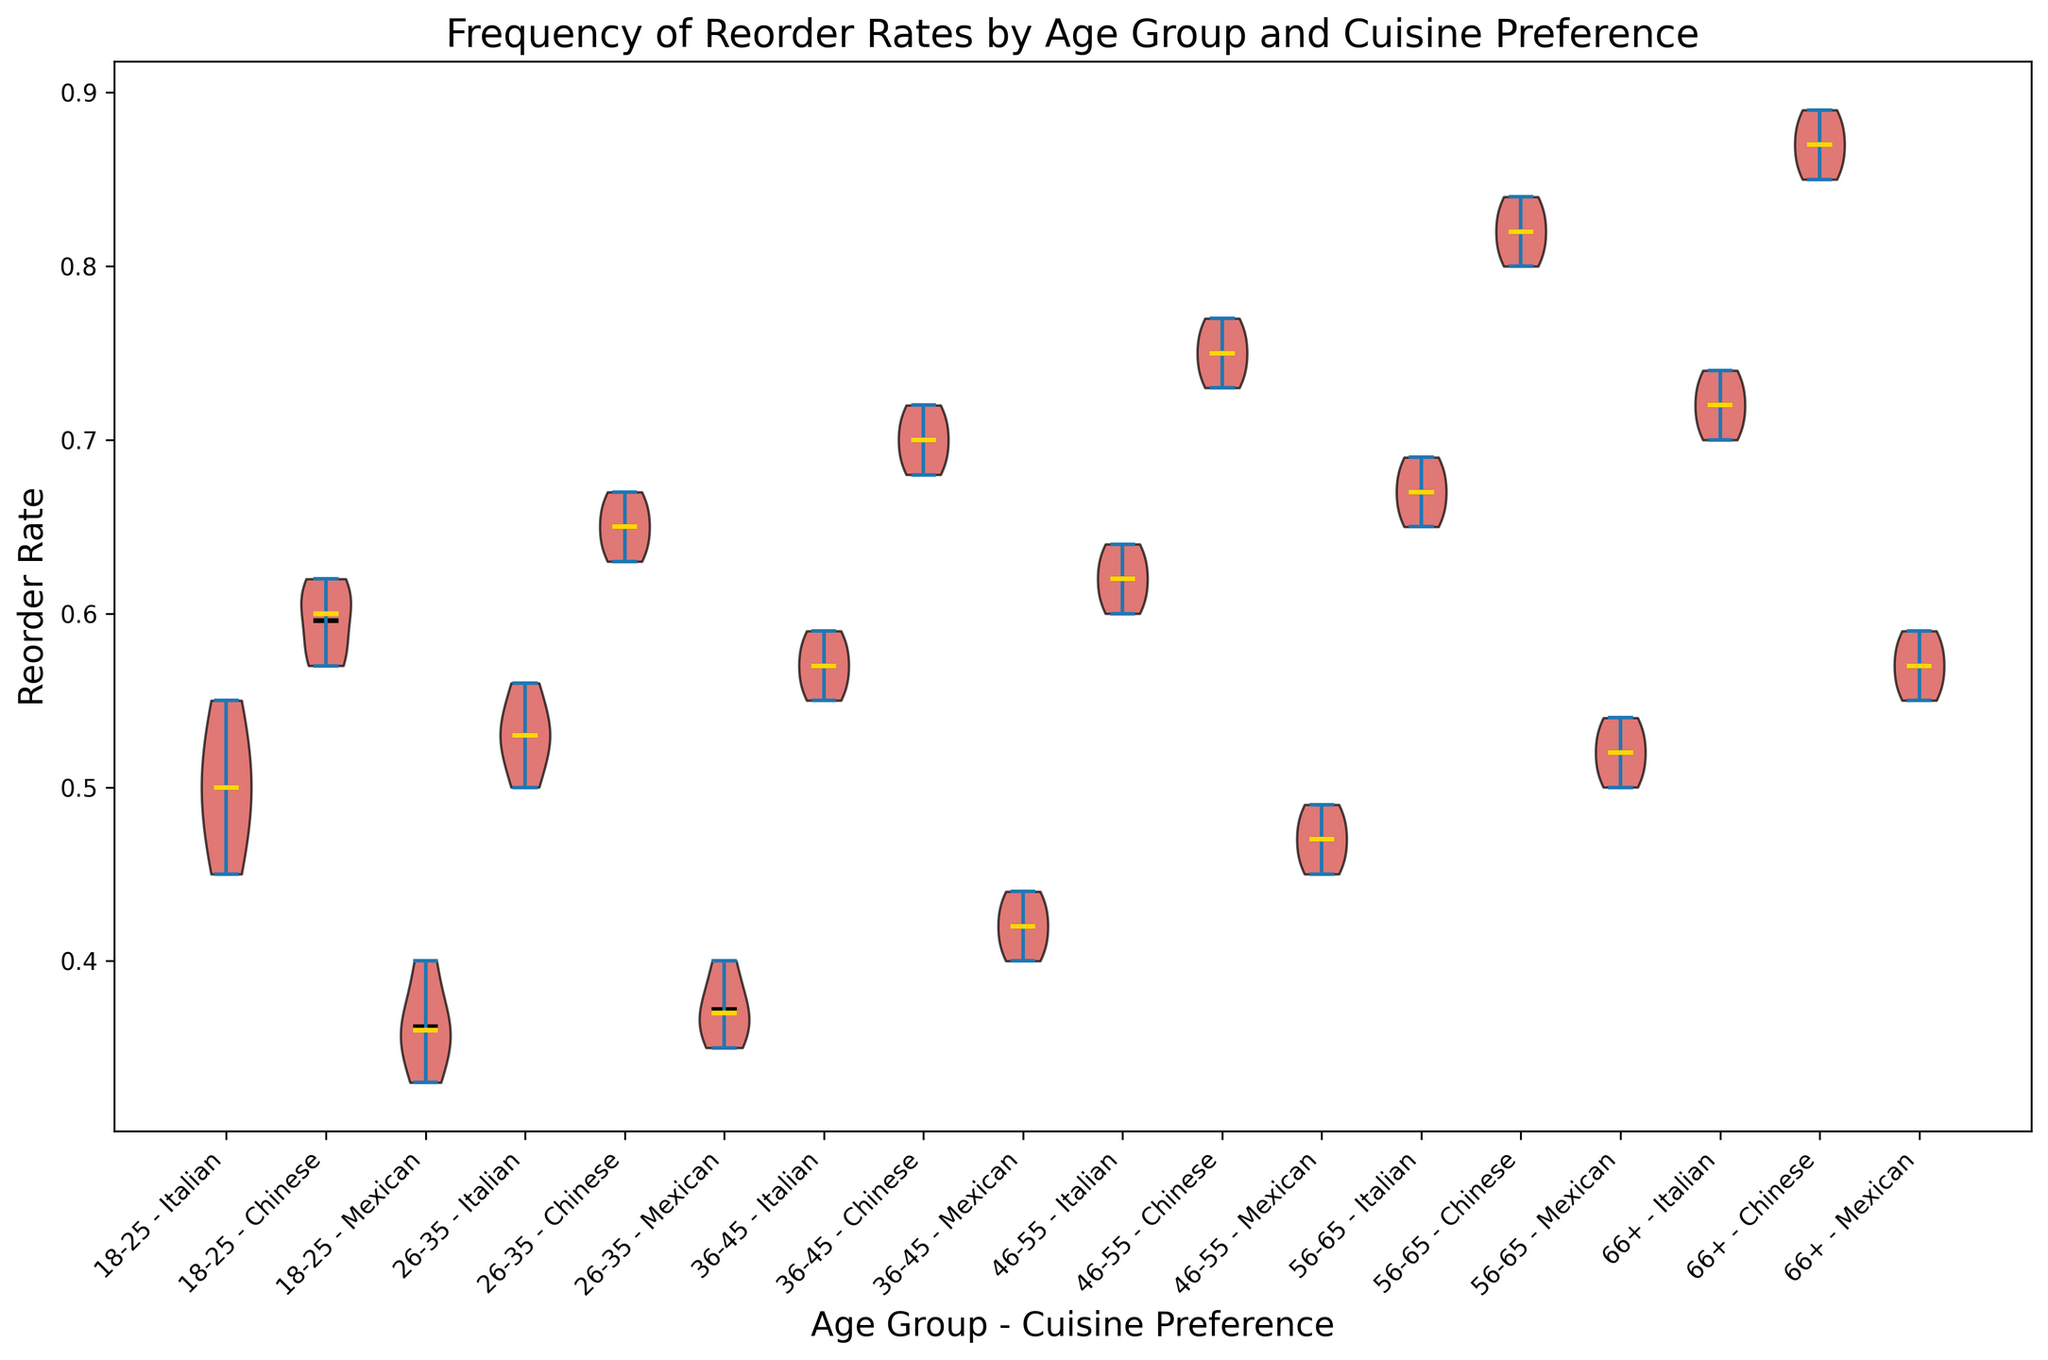What is the mean reorder rate for the age group 18-25 with a preference for Italian cuisine? First, find the data points for reorder rates within the age group 18-25 and with a preference for Italian cuisine (0.45, 0.50, 0.52, 0.55, 0.48), sum them up, and divide by the number of data points. The mean is (0.45+0.50+0.52+0.55+0.48) / 5 = 2.50 / 5
Answer: 0.50 Which age group has the widest range in reorder rates for Mexican cuisine? Compare the spread of the violin plots for Mexican cuisine across age groups. The age group 66+ shows the widest range visually.
Answer: 66+ Which cuisine preference has the highest mean reorder rate for the age group 26-35? Examine the mean positions within the violin plots for age group 26-35. The mean reorder rate is highest for Chinese cuisine within this age group.
Answer: Chinese Is the median reorder rate for Chinese cuisine higher in the age group 46-55 or 56-65? Observe the median lines within the violin plots for Chinese cuisine in age groups 46-55 and 56-65. The median is slightly higher for the 56-65 group.
Answer: 56-65 How does the reorder rate for Italian cuisine change from age group 18-25 to 46-55? Identify the mean/median positions in the violin plots for Italian cuisine across these age groups. The reorder rate increases progressively from 18-25 to 46-55.
Answer: Increases Which age group has a higher variability in reorder rates for Italian cuisine: 36-45 or 56-65? Analyze the spread and distribution density within the violin plots for these age groups. The plot for 36-45 shows less variability compared to 56-65.
Answer: 56-65 Does the age group 46-55 prefer Italian or Mexican cuisine more based on reorder rates? Compare the median lines and mean positions of violin plots for Italian and Mexican cuisine in the age group 46-55. Italian has a higher median reorder rate.
Answer: Italian What can you infer about the preference for Chinese cuisine by people aged 66+? The violin plot for Chinese cuisine in age group 66+ shows high values and a tight, concentrated range, indicating a strong preference.
Answer: Strong preference Among all age groups, which cuisine has the most consistently high reorder rates? Evaluate the overall height and concentration of the violin plots. Chinese cuisine presents consistently high reorder rates across all age groups.
Answer: Chinese 